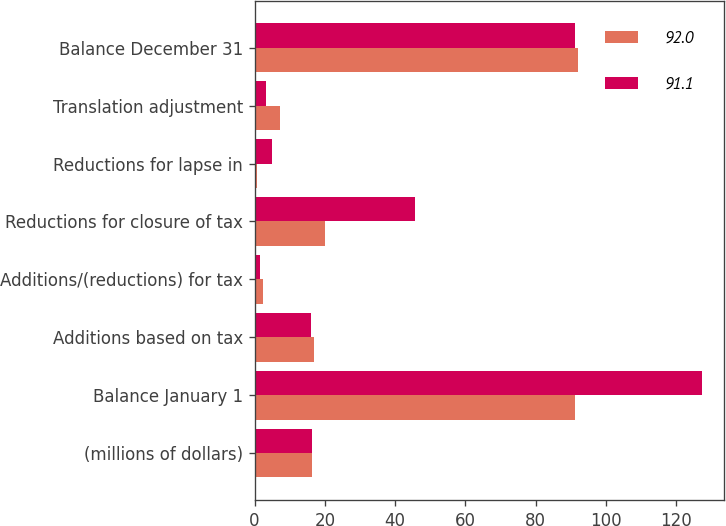Convert chart to OTSL. <chart><loc_0><loc_0><loc_500><loc_500><stacked_bar_chart><ecel><fcel>(millions of dollars)<fcel>Balance January 1<fcel>Additions based on tax<fcel>Additions/(reductions) for tax<fcel>Reductions for closure of tax<fcel>Reductions for lapse in<fcel>Translation adjustment<fcel>Balance December 31<nl><fcel>92<fcel>16.45<fcel>91.1<fcel>16.8<fcel>2.4<fcel>19.9<fcel>0.8<fcel>7.2<fcel>92<nl><fcel>91.1<fcel>16.45<fcel>127.3<fcel>16.1<fcel>1.6<fcel>45.7<fcel>5<fcel>3.2<fcel>91.1<nl></chart> 